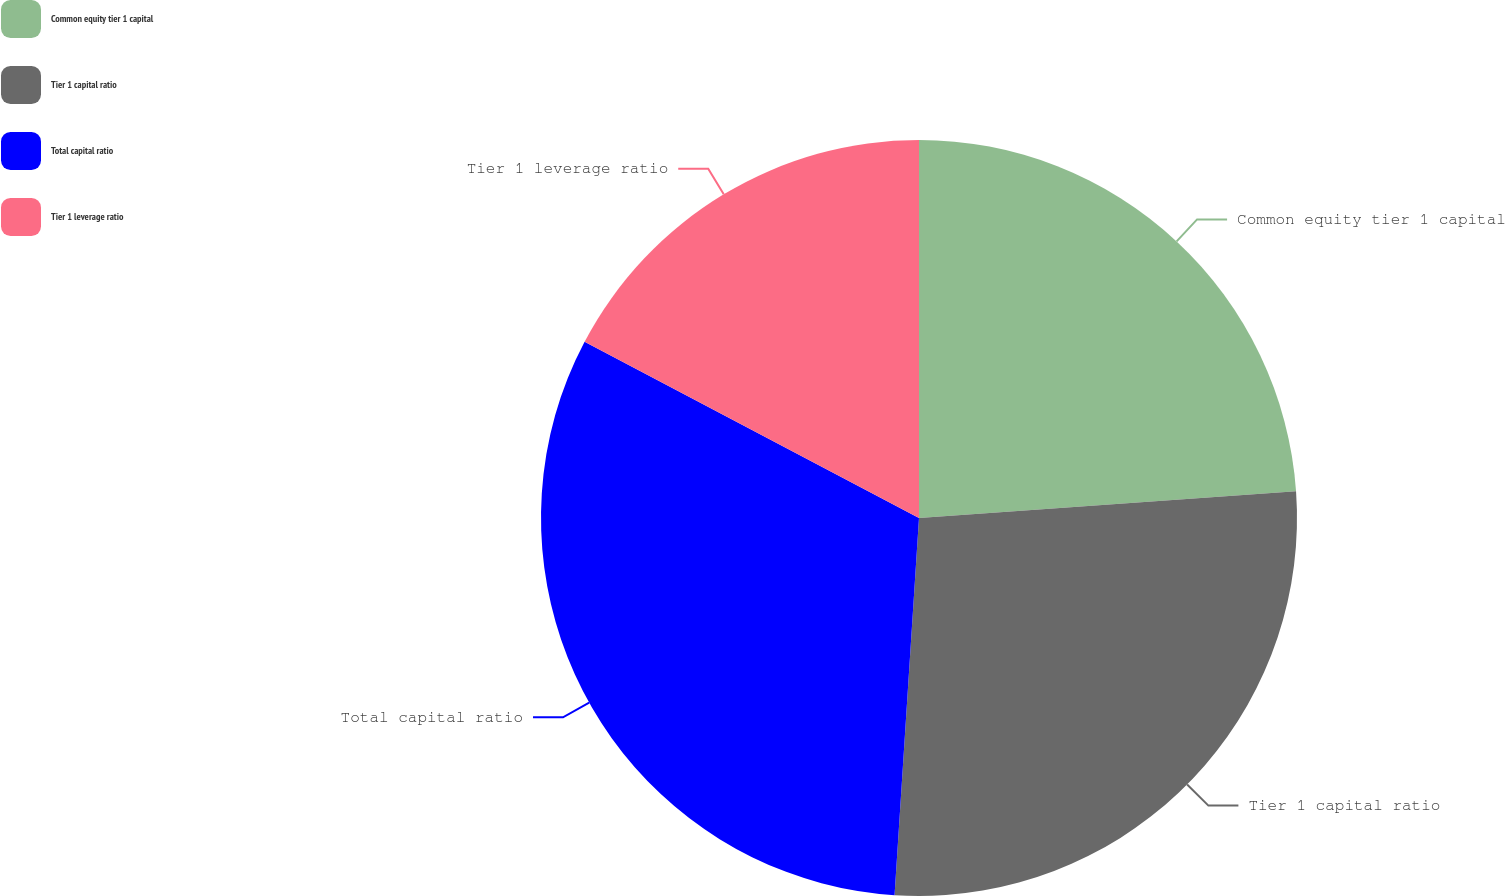Convert chart to OTSL. <chart><loc_0><loc_0><loc_500><loc_500><pie_chart><fcel>Common equity tier 1 capital<fcel>Tier 1 capital ratio<fcel>Total capital ratio<fcel>Tier 1 leverage ratio<nl><fcel>23.87%<fcel>27.16%<fcel>31.69%<fcel>17.28%<nl></chart> 